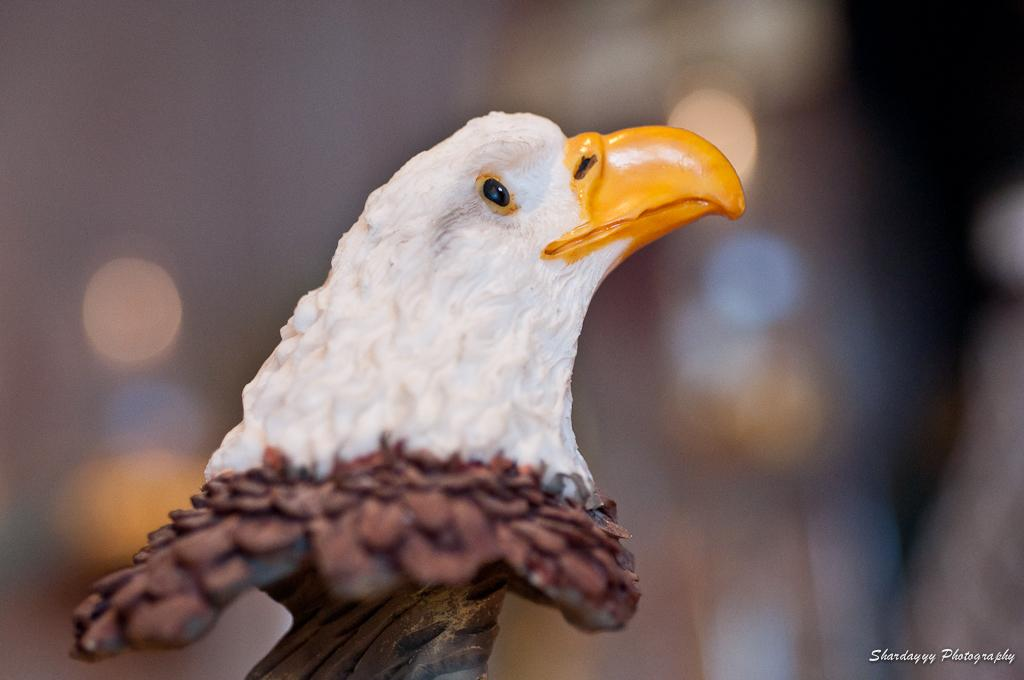What is the main subject of the image? The main subject of the image is a statue of an eagle. Where is the woman sitting on the dock during the event in the image? There is no woman, dock, or event present in the image; it only features a statue of an eagle. 